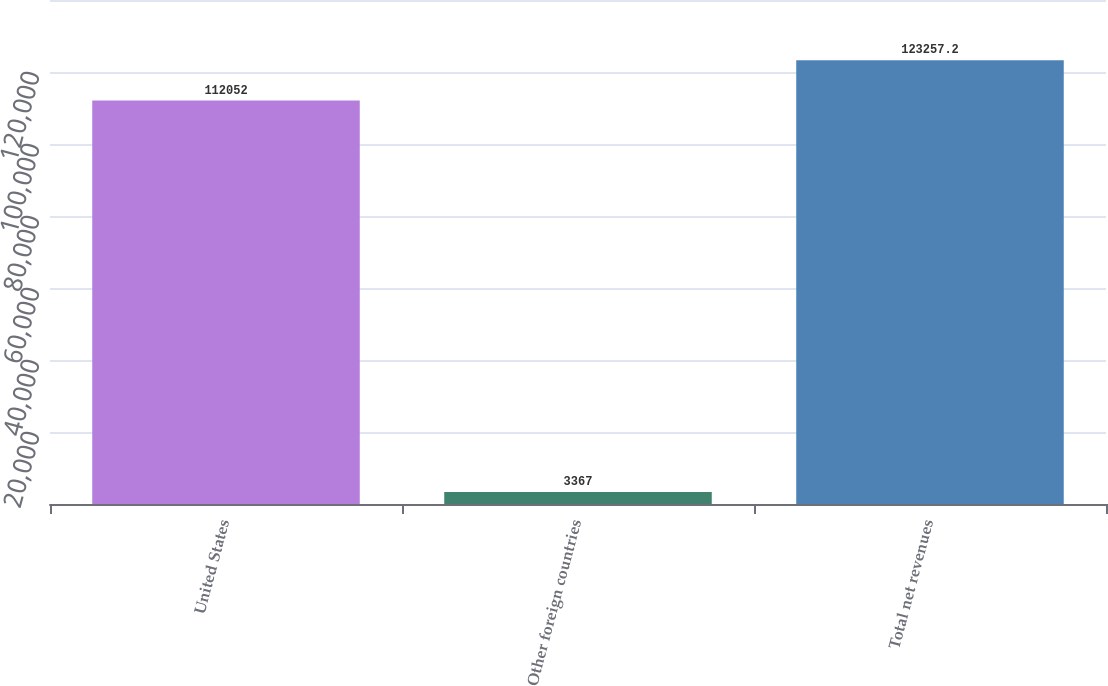Convert chart to OTSL. <chart><loc_0><loc_0><loc_500><loc_500><bar_chart><fcel>United States<fcel>Other foreign countries<fcel>Total net revenues<nl><fcel>112052<fcel>3367<fcel>123257<nl></chart> 